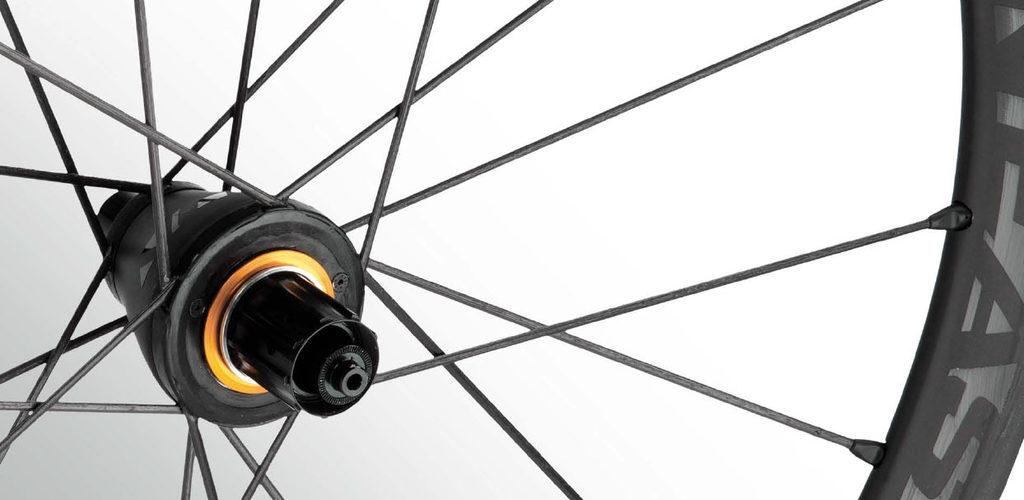What is: What is the main object in the image? There is a wheel with thin rods in the image. What color is the background of the image? The background of the image is white. What type of health advice can be seen in the image? There is no health advice present in the image; it features a wheel with thin rods against a white background. Can you describe the basketball scene in the image? There is no basketball scene present in the image; it features a wheel with thin rods against a white background. 